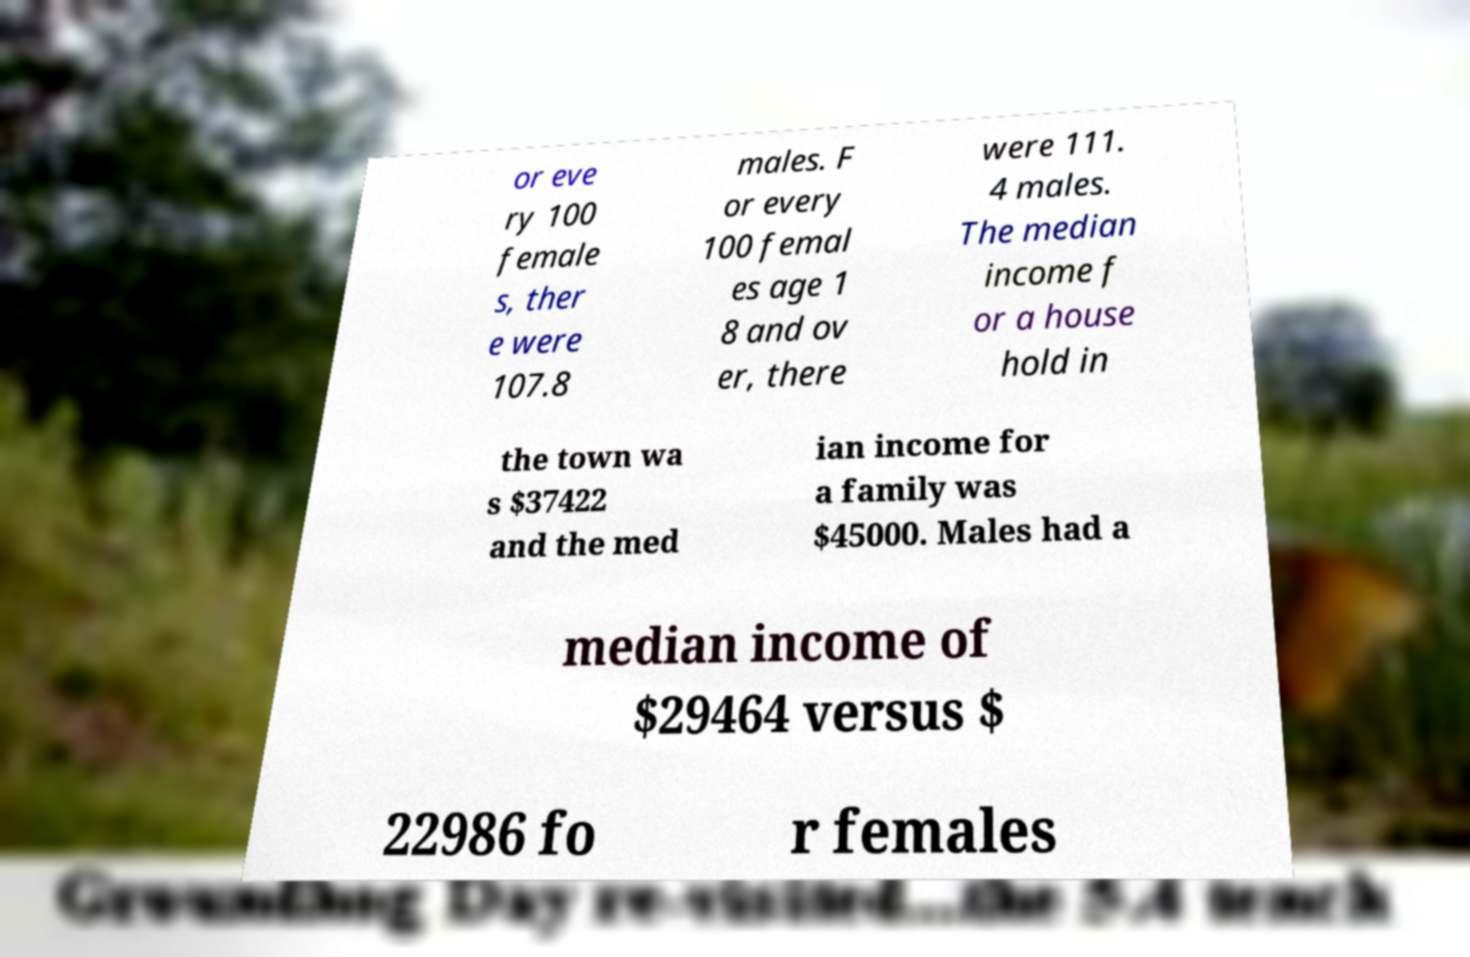There's text embedded in this image that I need extracted. Can you transcribe it verbatim? or eve ry 100 female s, ther e were 107.8 males. F or every 100 femal es age 1 8 and ov er, there were 111. 4 males. The median income f or a house hold in the town wa s $37422 and the med ian income for a family was $45000. Males had a median income of $29464 versus $ 22986 fo r females 